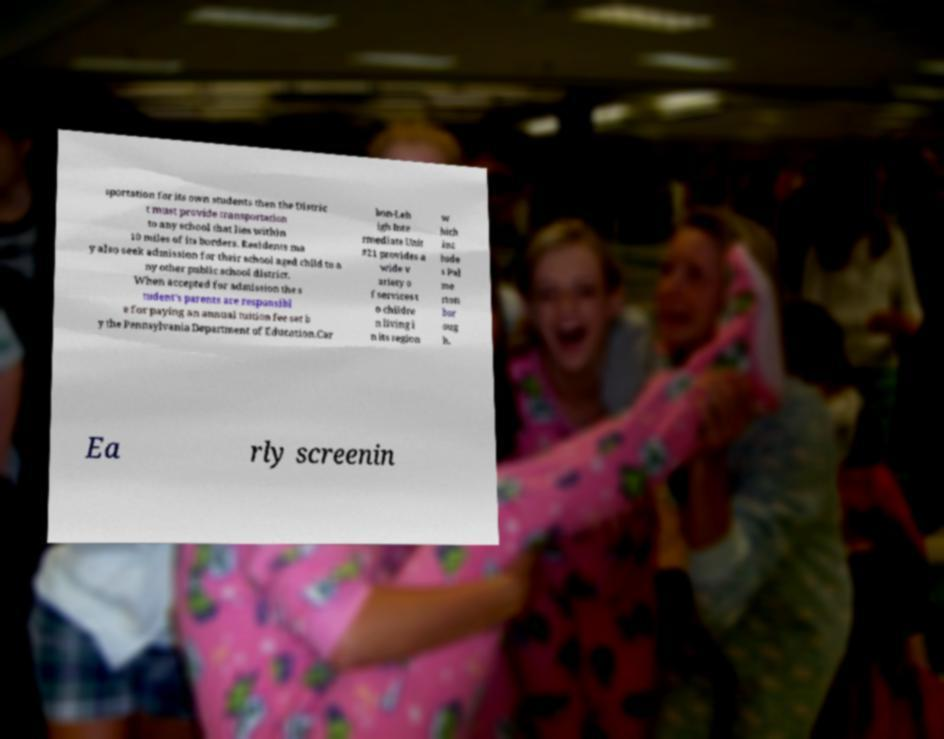Could you extract and type out the text from this image? sportation for its own students then the Distric t must provide transportation to any school that lies within 10 miles of its borders. Residents ma y also seek admission for their school aged child to a ny other public school district. When accepted for admission the s tudent's parents are responsibl e for paying an annual tuition fee set b y the Pennsylvania Department of Education.Car bon-Leh igh Inte rmediate Unit #21 provides a wide v ariety o f services t o childre n living i n its region w hich inc lude s Pal me rton bor oug h. Ea rly screenin 